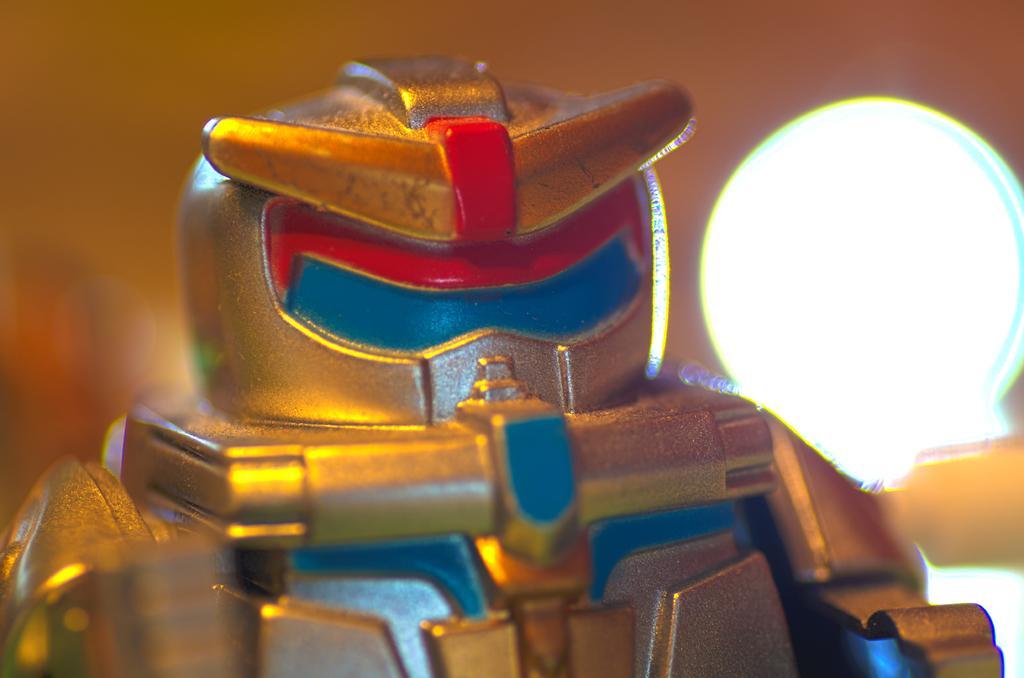Can you describe this image briefly? In front of the image there is a toy, behind the toy there is a lamp. 